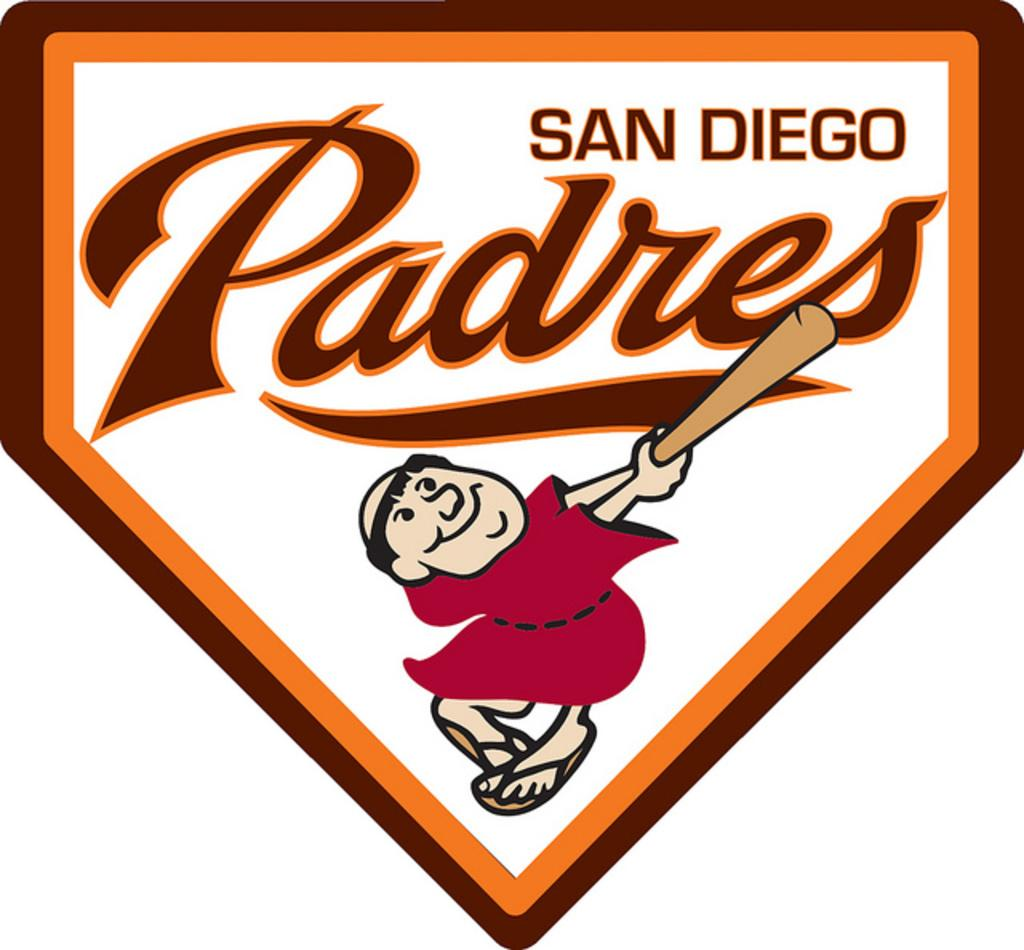What is the main subject of the image? There is a picture of a person in the image. What is the person holding in the image? The person is holding a baseball bat. What additional elements are present in the image besides the person and baseball bat? There is text above the animated picture, and there is a border around the text. What type of watch is the person wearing in the image? There is no watch visible in the image; the person is holding a baseball bat. Can you describe the minister in the image? There is no minister present in the image; it features a person holding a baseball bat. 